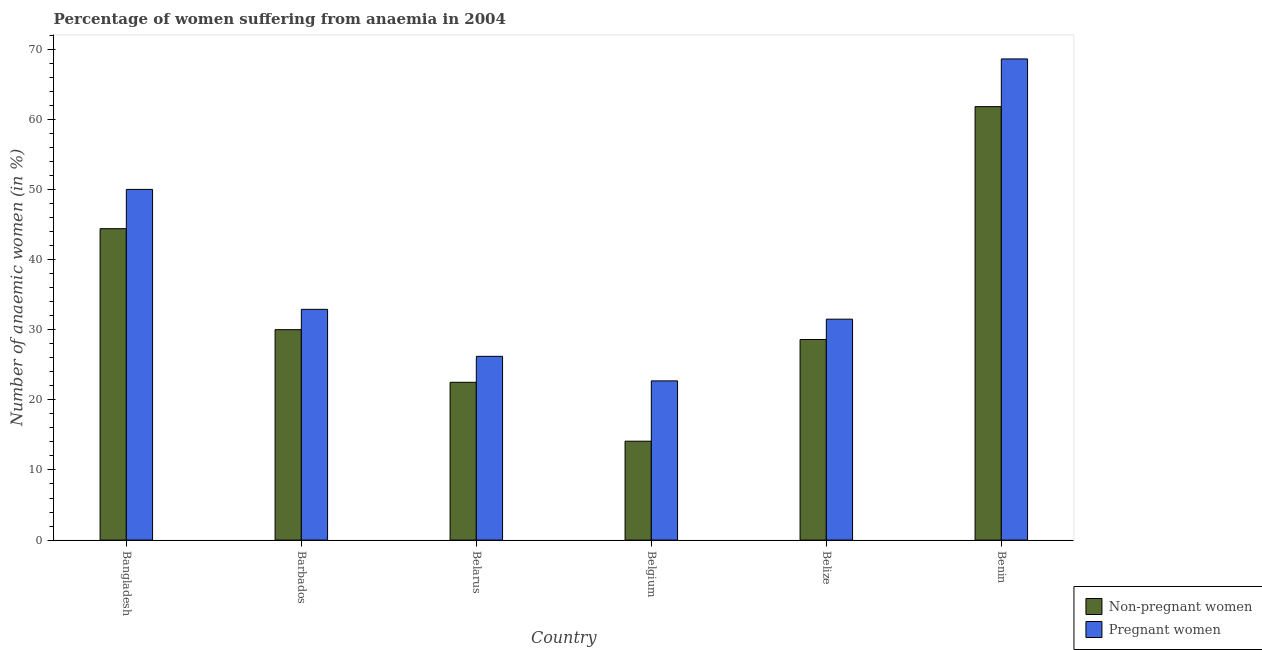Are the number of bars per tick equal to the number of legend labels?
Give a very brief answer. Yes. Are the number of bars on each tick of the X-axis equal?
Your response must be concise. Yes. How many bars are there on the 4th tick from the left?
Your answer should be compact. 2. How many bars are there on the 4th tick from the right?
Offer a terse response. 2. What is the label of the 1st group of bars from the left?
Give a very brief answer. Bangladesh. What is the percentage of non-pregnant anaemic women in Belize?
Provide a short and direct response. 28.6. Across all countries, what is the maximum percentage of pregnant anaemic women?
Provide a succinct answer. 68.6. In which country was the percentage of pregnant anaemic women maximum?
Your answer should be very brief. Benin. In which country was the percentage of non-pregnant anaemic women minimum?
Give a very brief answer. Belgium. What is the total percentage of non-pregnant anaemic women in the graph?
Provide a short and direct response. 201.4. What is the difference between the percentage of pregnant anaemic women in Bangladesh and the percentage of non-pregnant anaemic women in Belgium?
Ensure brevity in your answer.  35.9. What is the average percentage of pregnant anaemic women per country?
Provide a short and direct response. 38.65. What is the difference between the percentage of pregnant anaemic women and percentage of non-pregnant anaemic women in Belarus?
Provide a succinct answer. 3.7. What is the ratio of the percentage of pregnant anaemic women in Belarus to that in Belize?
Give a very brief answer. 0.83. Is the percentage of non-pregnant anaemic women in Bangladesh less than that in Benin?
Make the answer very short. Yes. What is the difference between the highest and the second highest percentage of pregnant anaemic women?
Provide a short and direct response. 18.6. What is the difference between the highest and the lowest percentage of non-pregnant anaemic women?
Offer a terse response. 47.7. What does the 2nd bar from the left in Bangladesh represents?
Your response must be concise. Pregnant women. What does the 1st bar from the right in Benin represents?
Your answer should be compact. Pregnant women. How many countries are there in the graph?
Keep it short and to the point. 6. What is the difference between two consecutive major ticks on the Y-axis?
Make the answer very short. 10. Where does the legend appear in the graph?
Provide a short and direct response. Bottom right. How are the legend labels stacked?
Your answer should be very brief. Vertical. What is the title of the graph?
Your answer should be very brief. Percentage of women suffering from anaemia in 2004. Does "Under-5(male)" appear as one of the legend labels in the graph?
Your answer should be compact. No. What is the label or title of the X-axis?
Keep it short and to the point. Country. What is the label or title of the Y-axis?
Make the answer very short. Number of anaemic women (in %). What is the Number of anaemic women (in %) of Non-pregnant women in Bangladesh?
Make the answer very short. 44.4. What is the Number of anaemic women (in %) of Pregnant women in Bangladesh?
Keep it short and to the point. 50. What is the Number of anaemic women (in %) of Pregnant women in Barbados?
Provide a short and direct response. 32.9. What is the Number of anaemic women (in %) in Pregnant women in Belarus?
Give a very brief answer. 26.2. What is the Number of anaemic women (in %) of Non-pregnant women in Belgium?
Ensure brevity in your answer.  14.1. What is the Number of anaemic women (in %) of Pregnant women in Belgium?
Offer a very short reply. 22.7. What is the Number of anaemic women (in %) in Non-pregnant women in Belize?
Ensure brevity in your answer.  28.6. What is the Number of anaemic women (in %) of Pregnant women in Belize?
Ensure brevity in your answer.  31.5. What is the Number of anaemic women (in %) of Non-pregnant women in Benin?
Offer a terse response. 61.8. What is the Number of anaemic women (in %) in Pregnant women in Benin?
Your answer should be very brief. 68.6. Across all countries, what is the maximum Number of anaemic women (in %) of Non-pregnant women?
Offer a terse response. 61.8. Across all countries, what is the maximum Number of anaemic women (in %) of Pregnant women?
Provide a succinct answer. 68.6. Across all countries, what is the minimum Number of anaemic women (in %) of Non-pregnant women?
Keep it short and to the point. 14.1. Across all countries, what is the minimum Number of anaemic women (in %) in Pregnant women?
Offer a very short reply. 22.7. What is the total Number of anaemic women (in %) of Non-pregnant women in the graph?
Provide a short and direct response. 201.4. What is the total Number of anaemic women (in %) in Pregnant women in the graph?
Keep it short and to the point. 231.9. What is the difference between the Number of anaemic women (in %) in Pregnant women in Bangladesh and that in Barbados?
Ensure brevity in your answer.  17.1. What is the difference between the Number of anaemic women (in %) in Non-pregnant women in Bangladesh and that in Belarus?
Offer a terse response. 21.9. What is the difference between the Number of anaemic women (in %) in Pregnant women in Bangladesh and that in Belarus?
Provide a short and direct response. 23.8. What is the difference between the Number of anaemic women (in %) of Non-pregnant women in Bangladesh and that in Belgium?
Keep it short and to the point. 30.3. What is the difference between the Number of anaemic women (in %) of Pregnant women in Bangladesh and that in Belgium?
Provide a short and direct response. 27.3. What is the difference between the Number of anaemic women (in %) of Non-pregnant women in Bangladesh and that in Belize?
Your answer should be very brief. 15.8. What is the difference between the Number of anaemic women (in %) of Non-pregnant women in Bangladesh and that in Benin?
Your answer should be compact. -17.4. What is the difference between the Number of anaemic women (in %) in Pregnant women in Bangladesh and that in Benin?
Your response must be concise. -18.6. What is the difference between the Number of anaemic women (in %) in Non-pregnant women in Barbados and that in Belarus?
Ensure brevity in your answer.  7.5. What is the difference between the Number of anaemic women (in %) in Pregnant women in Barbados and that in Belarus?
Provide a short and direct response. 6.7. What is the difference between the Number of anaemic women (in %) in Non-pregnant women in Barbados and that in Belgium?
Provide a short and direct response. 15.9. What is the difference between the Number of anaemic women (in %) in Pregnant women in Barbados and that in Belgium?
Your answer should be compact. 10.2. What is the difference between the Number of anaemic women (in %) in Non-pregnant women in Barbados and that in Benin?
Your answer should be very brief. -31.8. What is the difference between the Number of anaemic women (in %) of Pregnant women in Barbados and that in Benin?
Ensure brevity in your answer.  -35.7. What is the difference between the Number of anaemic women (in %) in Non-pregnant women in Belarus and that in Belgium?
Your answer should be very brief. 8.4. What is the difference between the Number of anaemic women (in %) in Pregnant women in Belarus and that in Belgium?
Ensure brevity in your answer.  3.5. What is the difference between the Number of anaemic women (in %) of Non-pregnant women in Belarus and that in Belize?
Provide a succinct answer. -6.1. What is the difference between the Number of anaemic women (in %) of Non-pregnant women in Belarus and that in Benin?
Provide a succinct answer. -39.3. What is the difference between the Number of anaemic women (in %) in Pregnant women in Belarus and that in Benin?
Ensure brevity in your answer.  -42.4. What is the difference between the Number of anaemic women (in %) of Non-pregnant women in Belgium and that in Belize?
Make the answer very short. -14.5. What is the difference between the Number of anaemic women (in %) of Non-pregnant women in Belgium and that in Benin?
Give a very brief answer. -47.7. What is the difference between the Number of anaemic women (in %) of Pregnant women in Belgium and that in Benin?
Provide a short and direct response. -45.9. What is the difference between the Number of anaemic women (in %) of Non-pregnant women in Belize and that in Benin?
Keep it short and to the point. -33.2. What is the difference between the Number of anaemic women (in %) in Pregnant women in Belize and that in Benin?
Keep it short and to the point. -37.1. What is the difference between the Number of anaemic women (in %) in Non-pregnant women in Bangladesh and the Number of anaemic women (in %) in Pregnant women in Belarus?
Make the answer very short. 18.2. What is the difference between the Number of anaemic women (in %) of Non-pregnant women in Bangladesh and the Number of anaemic women (in %) of Pregnant women in Belgium?
Make the answer very short. 21.7. What is the difference between the Number of anaemic women (in %) of Non-pregnant women in Bangladesh and the Number of anaemic women (in %) of Pregnant women in Benin?
Your answer should be compact. -24.2. What is the difference between the Number of anaemic women (in %) of Non-pregnant women in Barbados and the Number of anaemic women (in %) of Pregnant women in Belarus?
Your response must be concise. 3.8. What is the difference between the Number of anaemic women (in %) of Non-pregnant women in Barbados and the Number of anaemic women (in %) of Pregnant women in Belize?
Give a very brief answer. -1.5. What is the difference between the Number of anaemic women (in %) in Non-pregnant women in Barbados and the Number of anaemic women (in %) in Pregnant women in Benin?
Your answer should be very brief. -38.6. What is the difference between the Number of anaemic women (in %) in Non-pregnant women in Belarus and the Number of anaemic women (in %) in Pregnant women in Belize?
Your response must be concise. -9. What is the difference between the Number of anaemic women (in %) of Non-pregnant women in Belarus and the Number of anaemic women (in %) of Pregnant women in Benin?
Keep it short and to the point. -46.1. What is the difference between the Number of anaemic women (in %) of Non-pregnant women in Belgium and the Number of anaemic women (in %) of Pregnant women in Belize?
Your answer should be compact. -17.4. What is the difference between the Number of anaemic women (in %) of Non-pregnant women in Belgium and the Number of anaemic women (in %) of Pregnant women in Benin?
Provide a succinct answer. -54.5. What is the difference between the Number of anaemic women (in %) in Non-pregnant women in Belize and the Number of anaemic women (in %) in Pregnant women in Benin?
Offer a terse response. -40. What is the average Number of anaemic women (in %) in Non-pregnant women per country?
Provide a succinct answer. 33.57. What is the average Number of anaemic women (in %) in Pregnant women per country?
Provide a short and direct response. 38.65. What is the difference between the Number of anaemic women (in %) in Non-pregnant women and Number of anaemic women (in %) in Pregnant women in Belgium?
Your answer should be very brief. -8.6. What is the difference between the Number of anaemic women (in %) in Non-pregnant women and Number of anaemic women (in %) in Pregnant women in Belize?
Ensure brevity in your answer.  -2.9. What is the difference between the Number of anaemic women (in %) of Non-pregnant women and Number of anaemic women (in %) of Pregnant women in Benin?
Keep it short and to the point. -6.8. What is the ratio of the Number of anaemic women (in %) of Non-pregnant women in Bangladesh to that in Barbados?
Give a very brief answer. 1.48. What is the ratio of the Number of anaemic women (in %) of Pregnant women in Bangladesh to that in Barbados?
Provide a short and direct response. 1.52. What is the ratio of the Number of anaemic women (in %) in Non-pregnant women in Bangladesh to that in Belarus?
Give a very brief answer. 1.97. What is the ratio of the Number of anaemic women (in %) of Pregnant women in Bangladesh to that in Belarus?
Provide a short and direct response. 1.91. What is the ratio of the Number of anaemic women (in %) of Non-pregnant women in Bangladesh to that in Belgium?
Make the answer very short. 3.15. What is the ratio of the Number of anaemic women (in %) of Pregnant women in Bangladesh to that in Belgium?
Provide a short and direct response. 2.2. What is the ratio of the Number of anaemic women (in %) of Non-pregnant women in Bangladesh to that in Belize?
Your answer should be very brief. 1.55. What is the ratio of the Number of anaemic women (in %) of Pregnant women in Bangladesh to that in Belize?
Provide a short and direct response. 1.59. What is the ratio of the Number of anaemic women (in %) of Non-pregnant women in Bangladesh to that in Benin?
Offer a very short reply. 0.72. What is the ratio of the Number of anaemic women (in %) of Pregnant women in Bangladesh to that in Benin?
Ensure brevity in your answer.  0.73. What is the ratio of the Number of anaemic women (in %) in Non-pregnant women in Barbados to that in Belarus?
Make the answer very short. 1.33. What is the ratio of the Number of anaemic women (in %) in Pregnant women in Barbados to that in Belarus?
Ensure brevity in your answer.  1.26. What is the ratio of the Number of anaemic women (in %) in Non-pregnant women in Barbados to that in Belgium?
Keep it short and to the point. 2.13. What is the ratio of the Number of anaemic women (in %) in Pregnant women in Barbados to that in Belgium?
Keep it short and to the point. 1.45. What is the ratio of the Number of anaemic women (in %) of Non-pregnant women in Barbados to that in Belize?
Provide a short and direct response. 1.05. What is the ratio of the Number of anaemic women (in %) of Pregnant women in Barbados to that in Belize?
Make the answer very short. 1.04. What is the ratio of the Number of anaemic women (in %) of Non-pregnant women in Barbados to that in Benin?
Offer a very short reply. 0.49. What is the ratio of the Number of anaemic women (in %) of Pregnant women in Barbados to that in Benin?
Ensure brevity in your answer.  0.48. What is the ratio of the Number of anaemic women (in %) of Non-pregnant women in Belarus to that in Belgium?
Give a very brief answer. 1.6. What is the ratio of the Number of anaemic women (in %) in Pregnant women in Belarus to that in Belgium?
Ensure brevity in your answer.  1.15. What is the ratio of the Number of anaemic women (in %) in Non-pregnant women in Belarus to that in Belize?
Offer a terse response. 0.79. What is the ratio of the Number of anaemic women (in %) of Pregnant women in Belarus to that in Belize?
Provide a succinct answer. 0.83. What is the ratio of the Number of anaemic women (in %) in Non-pregnant women in Belarus to that in Benin?
Offer a very short reply. 0.36. What is the ratio of the Number of anaemic women (in %) in Pregnant women in Belarus to that in Benin?
Your answer should be compact. 0.38. What is the ratio of the Number of anaemic women (in %) in Non-pregnant women in Belgium to that in Belize?
Offer a very short reply. 0.49. What is the ratio of the Number of anaemic women (in %) in Pregnant women in Belgium to that in Belize?
Your response must be concise. 0.72. What is the ratio of the Number of anaemic women (in %) in Non-pregnant women in Belgium to that in Benin?
Keep it short and to the point. 0.23. What is the ratio of the Number of anaemic women (in %) in Pregnant women in Belgium to that in Benin?
Make the answer very short. 0.33. What is the ratio of the Number of anaemic women (in %) in Non-pregnant women in Belize to that in Benin?
Give a very brief answer. 0.46. What is the ratio of the Number of anaemic women (in %) of Pregnant women in Belize to that in Benin?
Make the answer very short. 0.46. What is the difference between the highest and the second highest Number of anaemic women (in %) of Pregnant women?
Provide a succinct answer. 18.6. What is the difference between the highest and the lowest Number of anaemic women (in %) of Non-pregnant women?
Offer a terse response. 47.7. What is the difference between the highest and the lowest Number of anaemic women (in %) of Pregnant women?
Ensure brevity in your answer.  45.9. 